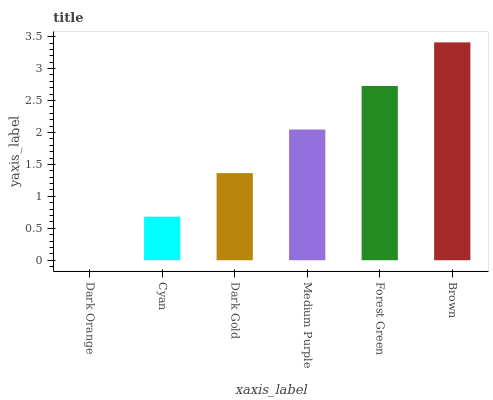Is Dark Orange the minimum?
Answer yes or no. Yes. Is Brown the maximum?
Answer yes or no. Yes. Is Cyan the minimum?
Answer yes or no. No. Is Cyan the maximum?
Answer yes or no. No. Is Cyan greater than Dark Orange?
Answer yes or no. Yes. Is Dark Orange less than Cyan?
Answer yes or no. Yes. Is Dark Orange greater than Cyan?
Answer yes or no. No. Is Cyan less than Dark Orange?
Answer yes or no. No. Is Medium Purple the high median?
Answer yes or no. Yes. Is Dark Gold the low median?
Answer yes or no. Yes. Is Dark Gold the high median?
Answer yes or no. No. Is Forest Green the low median?
Answer yes or no. No. 